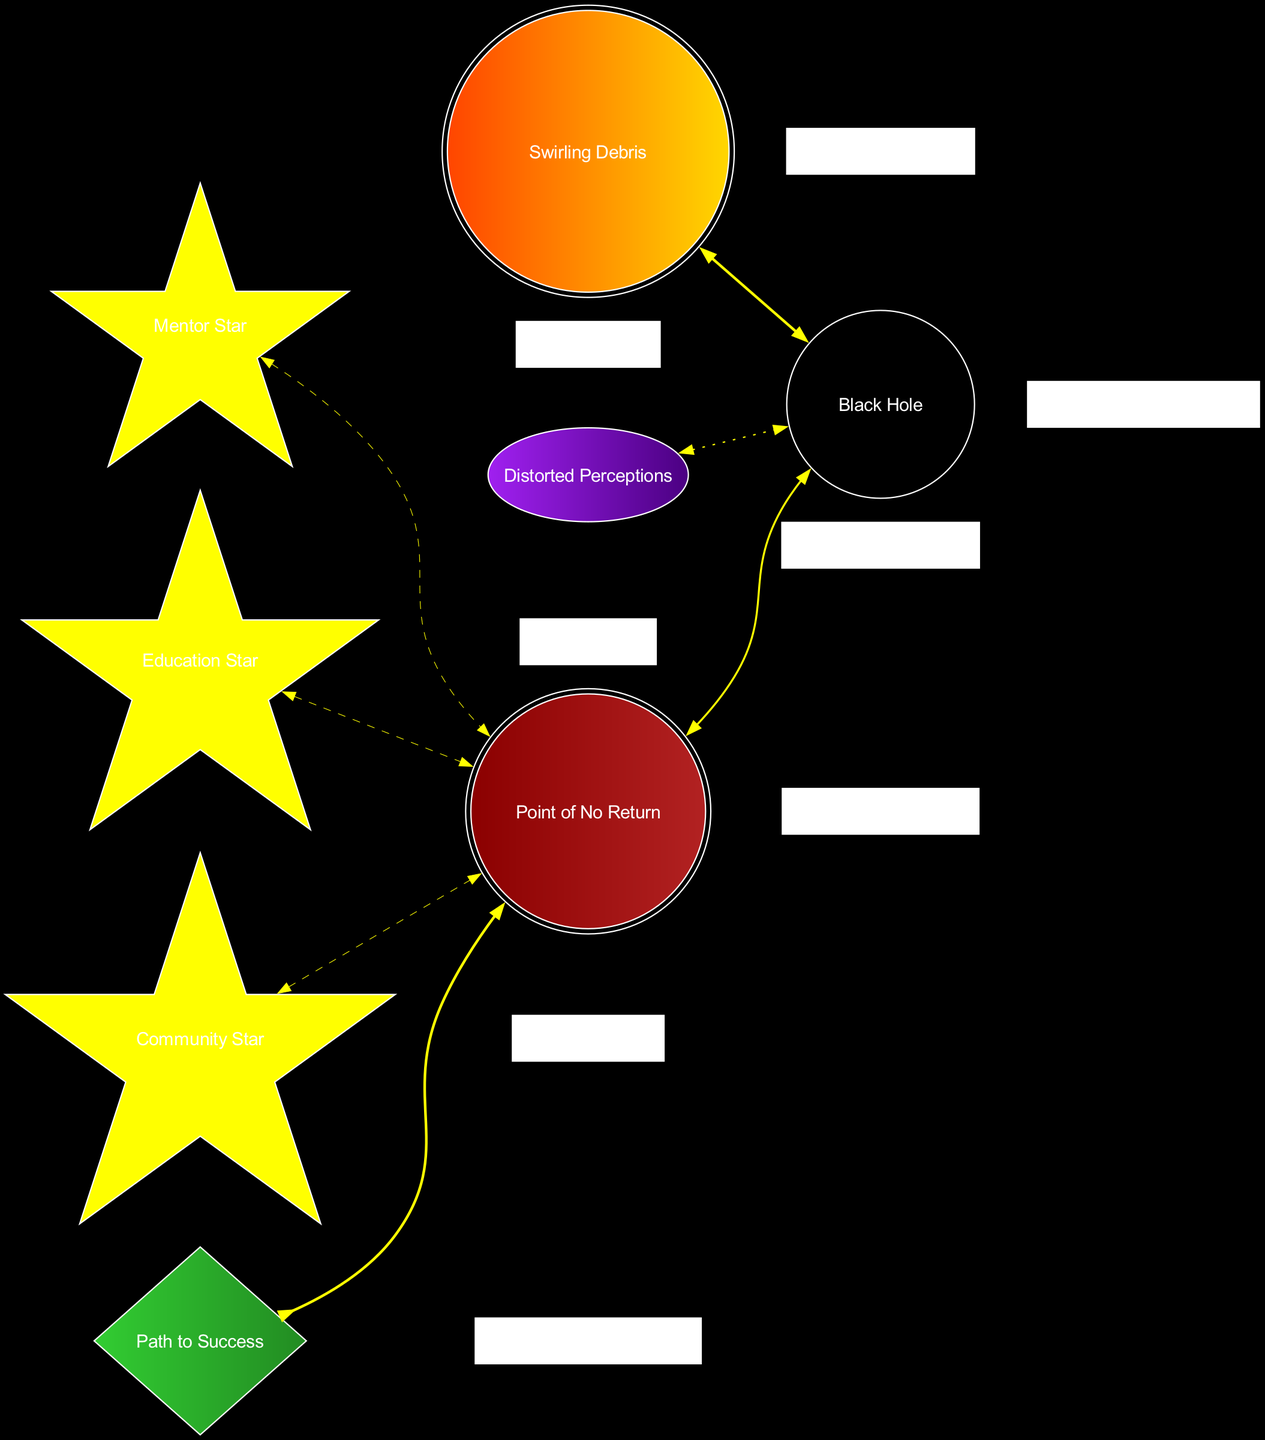What does the black hole represent? The central object in the diagram is labeled "Black Hole," indicating it represents overwhelming challenges faced by at-risk students.
Answer: Overwhelming challenges How many nearby stars are there? The diagram displays three nearby stars: Mentor Star, Education Star, and Community Star. These are visually distinct nodes positioned around the black hole.
Answer: 3 What does the event horizon symbolize? The "Point of No Return" is labeled as the event horizon in the diagram, indicating a critical juncture for intervention in a student’s challenges.
Answer: Critical juncture for intervention What is represented by the name "Escape Velocity"? The diamond-shaped node labeled "Escape Velocity" represents the "Path to Success," indicating a way to overcome challenges with support.
Answer: Path to Success Which star offers academic resources? The "Education Star" is explicitly labeled in the diagram as providing academic resources to students.
Answer: Education Star What is the significance of the gravitational lensing? The diagram's "Distorted Perceptions," represented by gravitational lensing, illustrates skewed self-image and outlook experienced by at-risk students.
Answer: Skewed self-image and outlook How do the nearby stars relate to the event horizon? Each nearby star is connected to the event horizon with dashed edges, indicating their role in providing support to prevent crossing the critical moment of intervention.
Answer: Provide support What visual shape is used to represent the accretion disk? The accretion disk is shaped as a double circle and is painted in an orangered to gold gradient, visually distinguishing it from other elements in the diagram.
Answer: Double circle What color represents the black hole? The black hole is visually represented in a solid black color, differentiating it as the main source of overwhelming challenges in the diagram.
Answer: Black 